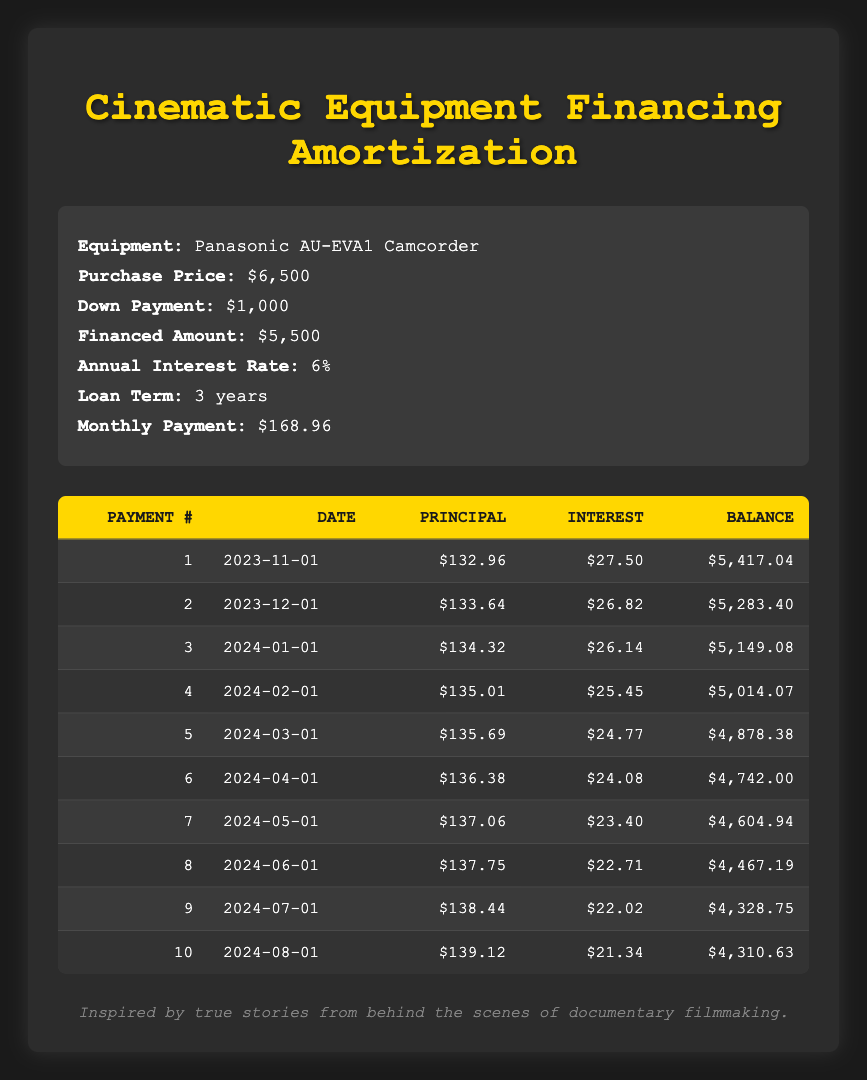What is the down payment for the Panasonic AU-EVA1 Camcorder? The down payment is explicitly listed in the equipment information section of the table, which shows that the down payment is $1,000.
Answer: $1,000 What is the financed amount for the equipment? The financed amount can be found directly in the equipment information section, and it states the financed amount is $5,500.
Answer: $5,500 How much is the total payment made towards the principal in the first three months? To find the total principal payment for the first three months, we add the principal payments from the first three rows: ($132.96 + $133.64 + $134.32) = $400.92.
Answer: $400.92 Is the interest payment in the second month less than the interest payment in the first month? The interest payment for the first month is $27.50, and for the second month, it is $26.82. Since $26.82 is less than $27.50, the statement is true.
Answer: Yes What is the average monthly principal payment over the first 10 months? First, we sum the principal payments for the first 10 months: ($132.96 + $133.64 + $134.32 + $135.01 + $135.69 + $136.38 + $137.06 + $137.75 + $138.44 + $139.12) = $1,360.37. To find the average, divide by 10, resulting in an average principal payment of $136.04.
Answer: $136.04 How much interest is paid in the last month? The table provides the interest payment for the last month (10th payment), which is $21.34.
Answer: $21.34 What is the remaining balance after the 5th payment? The remaining balance after the 5th payment is noted in the table, which shows that it is $4,878.38.
Answer: $4,878.38 What is the difference between the interest payment in the 1st month and the interest payment in the 10th month? The interest payment in the 1st month is $27.50 and in the 10th month is $21.34. The difference is calculated as $27.50 - $21.34 = $6.16.
Answer: $6.16 Are the principal payments increasing over the first ten months? By reviewing the principal payments, they show a consistent increase: ($132.96, $133.64, $134.32, ..., $139.12). Since each payment amount is greater than the previous, the answer is yes.
Answer: Yes 